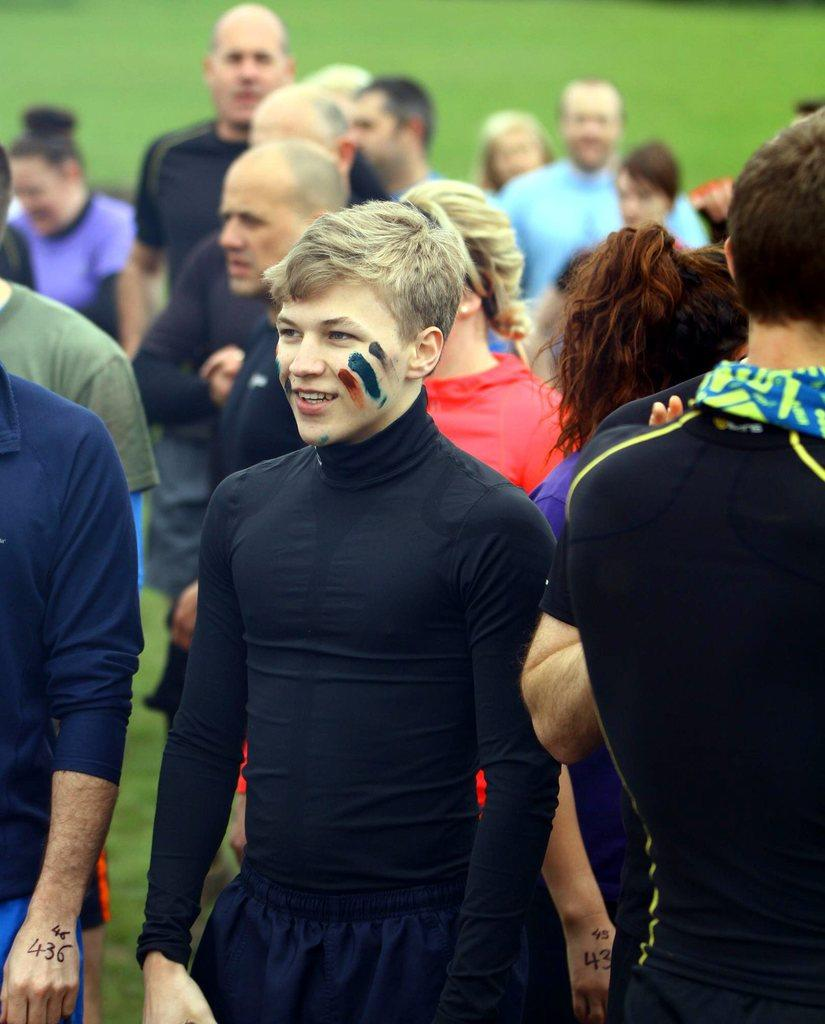What is the main subject of the image? The main subject of the image is a group of people. Where are the people located in the image? The group of people is standing in the center of the image. What type of environment is visible in the image? There is grassland visible in the image. Can you tell me how many fans are visible in the image? There are no fans present in the image; it features a group of people standing in the grassland. Are there any snails crawling on the people in the image? There is no indication of snails or any other creatures crawling on the people in the image. 